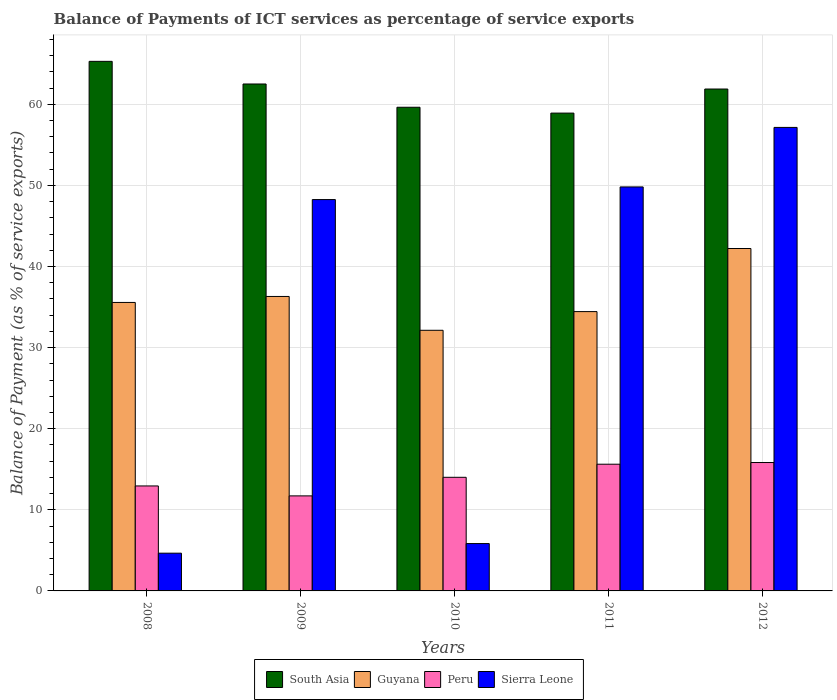How many groups of bars are there?
Make the answer very short. 5. Are the number of bars on each tick of the X-axis equal?
Your answer should be compact. Yes. How many bars are there on the 3rd tick from the right?
Keep it short and to the point. 4. What is the label of the 5th group of bars from the left?
Provide a short and direct response. 2012. In how many cases, is the number of bars for a given year not equal to the number of legend labels?
Give a very brief answer. 0. What is the balance of payments of ICT services in Peru in 2009?
Ensure brevity in your answer.  11.72. Across all years, what is the maximum balance of payments of ICT services in South Asia?
Keep it short and to the point. 65.3. Across all years, what is the minimum balance of payments of ICT services in Sierra Leone?
Offer a very short reply. 4.65. In which year was the balance of payments of ICT services in South Asia minimum?
Your answer should be compact. 2011. What is the total balance of payments of ICT services in South Asia in the graph?
Ensure brevity in your answer.  308.25. What is the difference between the balance of payments of ICT services in Peru in 2008 and that in 2011?
Provide a short and direct response. -2.68. What is the difference between the balance of payments of ICT services in Peru in 2011 and the balance of payments of ICT services in South Asia in 2012?
Provide a short and direct response. -46.26. What is the average balance of payments of ICT services in Sierra Leone per year?
Give a very brief answer. 33.14. In the year 2008, what is the difference between the balance of payments of ICT services in South Asia and balance of payments of ICT services in Sierra Leone?
Your answer should be very brief. 60.64. What is the ratio of the balance of payments of ICT services in South Asia in 2010 to that in 2012?
Keep it short and to the point. 0.96. What is the difference between the highest and the second highest balance of payments of ICT services in Peru?
Offer a very short reply. 0.21. What is the difference between the highest and the lowest balance of payments of ICT services in Guyana?
Provide a short and direct response. 10.08. In how many years, is the balance of payments of ICT services in Peru greater than the average balance of payments of ICT services in Peru taken over all years?
Provide a short and direct response. 2. Is it the case that in every year, the sum of the balance of payments of ICT services in Guyana and balance of payments of ICT services in South Asia is greater than the sum of balance of payments of ICT services in Sierra Leone and balance of payments of ICT services in Peru?
Make the answer very short. Yes. What does the 1st bar from the left in 2011 represents?
Keep it short and to the point. South Asia. What does the 4th bar from the right in 2011 represents?
Ensure brevity in your answer.  South Asia. What is the difference between two consecutive major ticks on the Y-axis?
Give a very brief answer. 10. Are the values on the major ticks of Y-axis written in scientific E-notation?
Offer a terse response. No. Does the graph contain any zero values?
Give a very brief answer. No. Where does the legend appear in the graph?
Your answer should be very brief. Bottom center. How many legend labels are there?
Ensure brevity in your answer.  4. How are the legend labels stacked?
Ensure brevity in your answer.  Horizontal. What is the title of the graph?
Your answer should be compact. Balance of Payments of ICT services as percentage of service exports. What is the label or title of the Y-axis?
Your response must be concise. Balance of Payment (as % of service exports). What is the Balance of Payment (as % of service exports) of South Asia in 2008?
Your answer should be compact. 65.3. What is the Balance of Payment (as % of service exports) of Guyana in 2008?
Your answer should be compact. 35.57. What is the Balance of Payment (as % of service exports) in Peru in 2008?
Keep it short and to the point. 12.94. What is the Balance of Payment (as % of service exports) of Sierra Leone in 2008?
Your response must be concise. 4.65. What is the Balance of Payment (as % of service exports) of South Asia in 2009?
Your answer should be very brief. 62.51. What is the Balance of Payment (as % of service exports) in Guyana in 2009?
Provide a succinct answer. 36.31. What is the Balance of Payment (as % of service exports) in Peru in 2009?
Your answer should be compact. 11.72. What is the Balance of Payment (as % of service exports) of Sierra Leone in 2009?
Offer a very short reply. 48.26. What is the Balance of Payment (as % of service exports) in South Asia in 2010?
Keep it short and to the point. 59.64. What is the Balance of Payment (as % of service exports) in Guyana in 2010?
Offer a terse response. 32.14. What is the Balance of Payment (as % of service exports) of Peru in 2010?
Your answer should be very brief. 14.01. What is the Balance of Payment (as % of service exports) in Sierra Leone in 2010?
Offer a terse response. 5.84. What is the Balance of Payment (as % of service exports) of South Asia in 2011?
Give a very brief answer. 58.92. What is the Balance of Payment (as % of service exports) in Guyana in 2011?
Make the answer very short. 34.44. What is the Balance of Payment (as % of service exports) in Peru in 2011?
Give a very brief answer. 15.62. What is the Balance of Payment (as % of service exports) in Sierra Leone in 2011?
Ensure brevity in your answer.  49.81. What is the Balance of Payment (as % of service exports) of South Asia in 2012?
Ensure brevity in your answer.  61.89. What is the Balance of Payment (as % of service exports) in Guyana in 2012?
Ensure brevity in your answer.  42.22. What is the Balance of Payment (as % of service exports) of Peru in 2012?
Your response must be concise. 15.83. What is the Balance of Payment (as % of service exports) of Sierra Leone in 2012?
Ensure brevity in your answer.  57.15. Across all years, what is the maximum Balance of Payment (as % of service exports) of South Asia?
Keep it short and to the point. 65.3. Across all years, what is the maximum Balance of Payment (as % of service exports) in Guyana?
Offer a terse response. 42.22. Across all years, what is the maximum Balance of Payment (as % of service exports) of Peru?
Provide a succinct answer. 15.83. Across all years, what is the maximum Balance of Payment (as % of service exports) in Sierra Leone?
Offer a terse response. 57.15. Across all years, what is the minimum Balance of Payment (as % of service exports) in South Asia?
Your answer should be very brief. 58.92. Across all years, what is the minimum Balance of Payment (as % of service exports) in Guyana?
Keep it short and to the point. 32.14. Across all years, what is the minimum Balance of Payment (as % of service exports) of Peru?
Give a very brief answer. 11.72. Across all years, what is the minimum Balance of Payment (as % of service exports) of Sierra Leone?
Offer a terse response. 4.65. What is the total Balance of Payment (as % of service exports) of South Asia in the graph?
Provide a short and direct response. 308.25. What is the total Balance of Payment (as % of service exports) in Guyana in the graph?
Give a very brief answer. 180.68. What is the total Balance of Payment (as % of service exports) in Peru in the graph?
Your answer should be very brief. 70.13. What is the total Balance of Payment (as % of service exports) of Sierra Leone in the graph?
Your response must be concise. 165.72. What is the difference between the Balance of Payment (as % of service exports) of South Asia in 2008 and that in 2009?
Your answer should be very brief. 2.79. What is the difference between the Balance of Payment (as % of service exports) in Guyana in 2008 and that in 2009?
Offer a very short reply. -0.74. What is the difference between the Balance of Payment (as % of service exports) of Peru in 2008 and that in 2009?
Keep it short and to the point. 1.22. What is the difference between the Balance of Payment (as % of service exports) in Sierra Leone in 2008 and that in 2009?
Keep it short and to the point. -43.6. What is the difference between the Balance of Payment (as % of service exports) of South Asia in 2008 and that in 2010?
Keep it short and to the point. 5.66. What is the difference between the Balance of Payment (as % of service exports) of Guyana in 2008 and that in 2010?
Give a very brief answer. 3.43. What is the difference between the Balance of Payment (as % of service exports) in Peru in 2008 and that in 2010?
Give a very brief answer. -1.07. What is the difference between the Balance of Payment (as % of service exports) in Sierra Leone in 2008 and that in 2010?
Provide a short and direct response. -1.18. What is the difference between the Balance of Payment (as % of service exports) in South Asia in 2008 and that in 2011?
Make the answer very short. 6.38. What is the difference between the Balance of Payment (as % of service exports) in Guyana in 2008 and that in 2011?
Offer a terse response. 1.13. What is the difference between the Balance of Payment (as % of service exports) of Peru in 2008 and that in 2011?
Your answer should be compact. -2.68. What is the difference between the Balance of Payment (as % of service exports) of Sierra Leone in 2008 and that in 2011?
Your answer should be very brief. -45.16. What is the difference between the Balance of Payment (as % of service exports) in South Asia in 2008 and that in 2012?
Provide a succinct answer. 3.41. What is the difference between the Balance of Payment (as % of service exports) in Guyana in 2008 and that in 2012?
Provide a short and direct response. -6.65. What is the difference between the Balance of Payment (as % of service exports) of Peru in 2008 and that in 2012?
Offer a terse response. -2.89. What is the difference between the Balance of Payment (as % of service exports) of Sierra Leone in 2008 and that in 2012?
Your answer should be very brief. -52.5. What is the difference between the Balance of Payment (as % of service exports) in South Asia in 2009 and that in 2010?
Make the answer very short. 2.87. What is the difference between the Balance of Payment (as % of service exports) in Guyana in 2009 and that in 2010?
Provide a short and direct response. 4.17. What is the difference between the Balance of Payment (as % of service exports) in Peru in 2009 and that in 2010?
Your response must be concise. -2.29. What is the difference between the Balance of Payment (as % of service exports) in Sierra Leone in 2009 and that in 2010?
Make the answer very short. 42.42. What is the difference between the Balance of Payment (as % of service exports) of South Asia in 2009 and that in 2011?
Offer a very short reply. 3.59. What is the difference between the Balance of Payment (as % of service exports) of Guyana in 2009 and that in 2011?
Keep it short and to the point. 1.87. What is the difference between the Balance of Payment (as % of service exports) of Peru in 2009 and that in 2011?
Offer a very short reply. -3.9. What is the difference between the Balance of Payment (as % of service exports) of Sierra Leone in 2009 and that in 2011?
Your answer should be very brief. -1.56. What is the difference between the Balance of Payment (as % of service exports) in South Asia in 2009 and that in 2012?
Offer a very short reply. 0.62. What is the difference between the Balance of Payment (as % of service exports) in Guyana in 2009 and that in 2012?
Your response must be concise. -5.91. What is the difference between the Balance of Payment (as % of service exports) in Peru in 2009 and that in 2012?
Offer a terse response. -4.11. What is the difference between the Balance of Payment (as % of service exports) of Sierra Leone in 2009 and that in 2012?
Make the answer very short. -8.9. What is the difference between the Balance of Payment (as % of service exports) in South Asia in 2010 and that in 2011?
Your response must be concise. 0.72. What is the difference between the Balance of Payment (as % of service exports) in Guyana in 2010 and that in 2011?
Keep it short and to the point. -2.3. What is the difference between the Balance of Payment (as % of service exports) of Peru in 2010 and that in 2011?
Give a very brief answer. -1.61. What is the difference between the Balance of Payment (as % of service exports) of Sierra Leone in 2010 and that in 2011?
Ensure brevity in your answer.  -43.98. What is the difference between the Balance of Payment (as % of service exports) of South Asia in 2010 and that in 2012?
Offer a very short reply. -2.25. What is the difference between the Balance of Payment (as % of service exports) in Guyana in 2010 and that in 2012?
Make the answer very short. -10.08. What is the difference between the Balance of Payment (as % of service exports) of Peru in 2010 and that in 2012?
Offer a terse response. -1.82. What is the difference between the Balance of Payment (as % of service exports) of Sierra Leone in 2010 and that in 2012?
Offer a terse response. -51.31. What is the difference between the Balance of Payment (as % of service exports) in South Asia in 2011 and that in 2012?
Make the answer very short. -2.97. What is the difference between the Balance of Payment (as % of service exports) in Guyana in 2011 and that in 2012?
Give a very brief answer. -7.78. What is the difference between the Balance of Payment (as % of service exports) of Peru in 2011 and that in 2012?
Offer a terse response. -0.21. What is the difference between the Balance of Payment (as % of service exports) in Sierra Leone in 2011 and that in 2012?
Offer a terse response. -7.34. What is the difference between the Balance of Payment (as % of service exports) of South Asia in 2008 and the Balance of Payment (as % of service exports) of Guyana in 2009?
Your answer should be very brief. 28.99. What is the difference between the Balance of Payment (as % of service exports) in South Asia in 2008 and the Balance of Payment (as % of service exports) in Peru in 2009?
Provide a short and direct response. 53.58. What is the difference between the Balance of Payment (as % of service exports) of South Asia in 2008 and the Balance of Payment (as % of service exports) of Sierra Leone in 2009?
Provide a succinct answer. 17.04. What is the difference between the Balance of Payment (as % of service exports) of Guyana in 2008 and the Balance of Payment (as % of service exports) of Peru in 2009?
Make the answer very short. 23.85. What is the difference between the Balance of Payment (as % of service exports) of Guyana in 2008 and the Balance of Payment (as % of service exports) of Sierra Leone in 2009?
Your answer should be compact. -12.69. What is the difference between the Balance of Payment (as % of service exports) in Peru in 2008 and the Balance of Payment (as % of service exports) in Sierra Leone in 2009?
Your answer should be compact. -35.31. What is the difference between the Balance of Payment (as % of service exports) in South Asia in 2008 and the Balance of Payment (as % of service exports) in Guyana in 2010?
Keep it short and to the point. 33.16. What is the difference between the Balance of Payment (as % of service exports) of South Asia in 2008 and the Balance of Payment (as % of service exports) of Peru in 2010?
Give a very brief answer. 51.29. What is the difference between the Balance of Payment (as % of service exports) of South Asia in 2008 and the Balance of Payment (as % of service exports) of Sierra Leone in 2010?
Offer a very short reply. 59.46. What is the difference between the Balance of Payment (as % of service exports) in Guyana in 2008 and the Balance of Payment (as % of service exports) in Peru in 2010?
Give a very brief answer. 21.56. What is the difference between the Balance of Payment (as % of service exports) of Guyana in 2008 and the Balance of Payment (as % of service exports) of Sierra Leone in 2010?
Make the answer very short. 29.73. What is the difference between the Balance of Payment (as % of service exports) in Peru in 2008 and the Balance of Payment (as % of service exports) in Sierra Leone in 2010?
Keep it short and to the point. 7.11. What is the difference between the Balance of Payment (as % of service exports) of South Asia in 2008 and the Balance of Payment (as % of service exports) of Guyana in 2011?
Make the answer very short. 30.86. What is the difference between the Balance of Payment (as % of service exports) of South Asia in 2008 and the Balance of Payment (as % of service exports) of Peru in 2011?
Offer a very short reply. 49.68. What is the difference between the Balance of Payment (as % of service exports) in South Asia in 2008 and the Balance of Payment (as % of service exports) in Sierra Leone in 2011?
Your answer should be compact. 15.48. What is the difference between the Balance of Payment (as % of service exports) of Guyana in 2008 and the Balance of Payment (as % of service exports) of Peru in 2011?
Your answer should be very brief. 19.95. What is the difference between the Balance of Payment (as % of service exports) of Guyana in 2008 and the Balance of Payment (as % of service exports) of Sierra Leone in 2011?
Provide a short and direct response. -14.24. What is the difference between the Balance of Payment (as % of service exports) in Peru in 2008 and the Balance of Payment (as % of service exports) in Sierra Leone in 2011?
Offer a terse response. -36.87. What is the difference between the Balance of Payment (as % of service exports) of South Asia in 2008 and the Balance of Payment (as % of service exports) of Guyana in 2012?
Offer a terse response. 23.08. What is the difference between the Balance of Payment (as % of service exports) of South Asia in 2008 and the Balance of Payment (as % of service exports) of Peru in 2012?
Keep it short and to the point. 49.47. What is the difference between the Balance of Payment (as % of service exports) in South Asia in 2008 and the Balance of Payment (as % of service exports) in Sierra Leone in 2012?
Your answer should be compact. 8.15. What is the difference between the Balance of Payment (as % of service exports) of Guyana in 2008 and the Balance of Payment (as % of service exports) of Peru in 2012?
Provide a succinct answer. 19.74. What is the difference between the Balance of Payment (as % of service exports) in Guyana in 2008 and the Balance of Payment (as % of service exports) in Sierra Leone in 2012?
Offer a terse response. -21.58. What is the difference between the Balance of Payment (as % of service exports) in Peru in 2008 and the Balance of Payment (as % of service exports) in Sierra Leone in 2012?
Your answer should be very brief. -44.21. What is the difference between the Balance of Payment (as % of service exports) in South Asia in 2009 and the Balance of Payment (as % of service exports) in Guyana in 2010?
Give a very brief answer. 30.37. What is the difference between the Balance of Payment (as % of service exports) in South Asia in 2009 and the Balance of Payment (as % of service exports) in Peru in 2010?
Your answer should be very brief. 48.5. What is the difference between the Balance of Payment (as % of service exports) of South Asia in 2009 and the Balance of Payment (as % of service exports) of Sierra Leone in 2010?
Provide a short and direct response. 56.67. What is the difference between the Balance of Payment (as % of service exports) of Guyana in 2009 and the Balance of Payment (as % of service exports) of Peru in 2010?
Ensure brevity in your answer.  22.3. What is the difference between the Balance of Payment (as % of service exports) of Guyana in 2009 and the Balance of Payment (as % of service exports) of Sierra Leone in 2010?
Offer a terse response. 30.47. What is the difference between the Balance of Payment (as % of service exports) of Peru in 2009 and the Balance of Payment (as % of service exports) of Sierra Leone in 2010?
Provide a succinct answer. 5.88. What is the difference between the Balance of Payment (as % of service exports) of South Asia in 2009 and the Balance of Payment (as % of service exports) of Guyana in 2011?
Make the answer very short. 28.07. What is the difference between the Balance of Payment (as % of service exports) in South Asia in 2009 and the Balance of Payment (as % of service exports) in Peru in 2011?
Your response must be concise. 46.88. What is the difference between the Balance of Payment (as % of service exports) in South Asia in 2009 and the Balance of Payment (as % of service exports) in Sierra Leone in 2011?
Keep it short and to the point. 12.69. What is the difference between the Balance of Payment (as % of service exports) in Guyana in 2009 and the Balance of Payment (as % of service exports) in Peru in 2011?
Give a very brief answer. 20.69. What is the difference between the Balance of Payment (as % of service exports) of Guyana in 2009 and the Balance of Payment (as % of service exports) of Sierra Leone in 2011?
Your answer should be compact. -13.5. What is the difference between the Balance of Payment (as % of service exports) of Peru in 2009 and the Balance of Payment (as % of service exports) of Sierra Leone in 2011?
Your answer should be very brief. -38.09. What is the difference between the Balance of Payment (as % of service exports) in South Asia in 2009 and the Balance of Payment (as % of service exports) in Guyana in 2012?
Your response must be concise. 20.29. What is the difference between the Balance of Payment (as % of service exports) in South Asia in 2009 and the Balance of Payment (as % of service exports) in Peru in 2012?
Your response must be concise. 46.68. What is the difference between the Balance of Payment (as % of service exports) in South Asia in 2009 and the Balance of Payment (as % of service exports) in Sierra Leone in 2012?
Make the answer very short. 5.35. What is the difference between the Balance of Payment (as % of service exports) in Guyana in 2009 and the Balance of Payment (as % of service exports) in Peru in 2012?
Provide a short and direct response. 20.48. What is the difference between the Balance of Payment (as % of service exports) in Guyana in 2009 and the Balance of Payment (as % of service exports) in Sierra Leone in 2012?
Offer a very short reply. -20.84. What is the difference between the Balance of Payment (as % of service exports) in Peru in 2009 and the Balance of Payment (as % of service exports) in Sierra Leone in 2012?
Offer a terse response. -45.43. What is the difference between the Balance of Payment (as % of service exports) in South Asia in 2010 and the Balance of Payment (as % of service exports) in Guyana in 2011?
Your answer should be very brief. 25.2. What is the difference between the Balance of Payment (as % of service exports) of South Asia in 2010 and the Balance of Payment (as % of service exports) of Peru in 2011?
Your response must be concise. 44.02. What is the difference between the Balance of Payment (as % of service exports) of South Asia in 2010 and the Balance of Payment (as % of service exports) of Sierra Leone in 2011?
Offer a terse response. 9.82. What is the difference between the Balance of Payment (as % of service exports) of Guyana in 2010 and the Balance of Payment (as % of service exports) of Peru in 2011?
Your answer should be compact. 16.51. What is the difference between the Balance of Payment (as % of service exports) in Guyana in 2010 and the Balance of Payment (as % of service exports) in Sierra Leone in 2011?
Your response must be concise. -17.68. What is the difference between the Balance of Payment (as % of service exports) in Peru in 2010 and the Balance of Payment (as % of service exports) in Sierra Leone in 2011?
Make the answer very short. -35.8. What is the difference between the Balance of Payment (as % of service exports) in South Asia in 2010 and the Balance of Payment (as % of service exports) in Guyana in 2012?
Offer a terse response. 17.42. What is the difference between the Balance of Payment (as % of service exports) of South Asia in 2010 and the Balance of Payment (as % of service exports) of Peru in 2012?
Offer a very short reply. 43.81. What is the difference between the Balance of Payment (as % of service exports) in South Asia in 2010 and the Balance of Payment (as % of service exports) in Sierra Leone in 2012?
Your response must be concise. 2.49. What is the difference between the Balance of Payment (as % of service exports) of Guyana in 2010 and the Balance of Payment (as % of service exports) of Peru in 2012?
Keep it short and to the point. 16.3. What is the difference between the Balance of Payment (as % of service exports) of Guyana in 2010 and the Balance of Payment (as % of service exports) of Sierra Leone in 2012?
Offer a terse response. -25.02. What is the difference between the Balance of Payment (as % of service exports) of Peru in 2010 and the Balance of Payment (as % of service exports) of Sierra Leone in 2012?
Keep it short and to the point. -43.14. What is the difference between the Balance of Payment (as % of service exports) of South Asia in 2011 and the Balance of Payment (as % of service exports) of Guyana in 2012?
Your response must be concise. 16.7. What is the difference between the Balance of Payment (as % of service exports) in South Asia in 2011 and the Balance of Payment (as % of service exports) in Peru in 2012?
Your answer should be compact. 43.08. What is the difference between the Balance of Payment (as % of service exports) of South Asia in 2011 and the Balance of Payment (as % of service exports) of Sierra Leone in 2012?
Your answer should be compact. 1.76. What is the difference between the Balance of Payment (as % of service exports) in Guyana in 2011 and the Balance of Payment (as % of service exports) in Peru in 2012?
Provide a succinct answer. 18.61. What is the difference between the Balance of Payment (as % of service exports) of Guyana in 2011 and the Balance of Payment (as % of service exports) of Sierra Leone in 2012?
Offer a terse response. -22.71. What is the difference between the Balance of Payment (as % of service exports) in Peru in 2011 and the Balance of Payment (as % of service exports) in Sierra Leone in 2012?
Your answer should be compact. -41.53. What is the average Balance of Payment (as % of service exports) in South Asia per year?
Offer a very short reply. 61.65. What is the average Balance of Payment (as % of service exports) in Guyana per year?
Offer a very short reply. 36.14. What is the average Balance of Payment (as % of service exports) of Peru per year?
Ensure brevity in your answer.  14.03. What is the average Balance of Payment (as % of service exports) of Sierra Leone per year?
Give a very brief answer. 33.14. In the year 2008, what is the difference between the Balance of Payment (as % of service exports) of South Asia and Balance of Payment (as % of service exports) of Guyana?
Provide a short and direct response. 29.73. In the year 2008, what is the difference between the Balance of Payment (as % of service exports) of South Asia and Balance of Payment (as % of service exports) of Peru?
Ensure brevity in your answer.  52.35. In the year 2008, what is the difference between the Balance of Payment (as % of service exports) in South Asia and Balance of Payment (as % of service exports) in Sierra Leone?
Your answer should be compact. 60.64. In the year 2008, what is the difference between the Balance of Payment (as % of service exports) of Guyana and Balance of Payment (as % of service exports) of Peru?
Your response must be concise. 22.63. In the year 2008, what is the difference between the Balance of Payment (as % of service exports) of Guyana and Balance of Payment (as % of service exports) of Sierra Leone?
Provide a succinct answer. 30.92. In the year 2008, what is the difference between the Balance of Payment (as % of service exports) in Peru and Balance of Payment (as % of service exports) in Sierra Leone?
Your answer should be compact. 8.29. In the year 2009, what is the difference between the Balance of Payment (as % of service exports) of South Asia and Balance of Payment (as % of service exports) of Guyana?
Offer a very short reply. 26.2. In the year 2009, what is the difference between the Balance of Payment (as % of service exports) of South Asia and Balance of Payment (as % of service exports) of Peru?
Provide a short and direct response. 50.79. In the year 2009, what is the difference between the Balance of Payment (as % of service exports) of South Asia and Balance of Payment (as % of service exports) of Sierra Leone?
Offer a very short reply. 14.25. In the year 2009, what is the difference between the Balance of Payment (as % of service exports) in Guyana and Balance of Payment (as % of service exports) in Peru?
Ensure brevity in your answer.  24.59. In the year 2009, what is the difference between the Balance of Payment (as % of service exports) of Guyana and Balance of Payment (as % of service exports) of Sierra Leone?
Offer a very short reply. -11.95. In the year 2009, what is the difference between the Balance of Payment (as % of service exports) of Peru and Balance of Payment (as % of service exports) of Sierra Leone?
Keep it short and to the point. -36.54. In the year 2010, what is the difference between the Balance of Payment (as % of service exports) in South Asia and Balance of Payment (as % of service exports) in Guyana?
Make the answer very short. 27.5. In the year 2010, what is the difference between the Balance of Payment (as % of service exports) in South Asia and Balance of Payment (as % of service exports) in Peru?
Your answer should be very brief. 45.63. In the year 2010, what is the difference between the Balance of Payment (as % of service exports) of South Asia and Balance of Payment (as % of service exports) of Sierra Leone?
Provide a short and direct response. 53.8. In the year 2010, what is the difference between the Balance of Payment (as % of service exports) of Guyana and Balance of Payment (as % of service exports) of Peru?
Make the answer very short. 18.13. In the year 2010, what is the difference between the Balance of Payment (as % of service exports) of Guyana and Balance of Payment (as % of service exports) of Sierra Leone?
Provide a succinct answer. 26.3. In the year 2010, what is the difference between the Balance of Payment (as % of service exports) of Peru and Balance of Payment (as % of service exports) of Sierra Leone?
Keep it short and to the point. 8.17. In the year 2011, what is the difference between the Balance of Payment (as % of service exports) of South Asia and Balance of Payment (as % of service exports) of Guyana?
Your answer should be very brief. 24.48. In the year 2011, what is the difference between the Balance of Payment (as % of service exports) of South Asia and Balance of Payment (as % of service exports) of Peru?
Keep it short and to the point. 43.29. In the year 2011, what is the difference between the Balance of Payment (as % of service exports) in South Asia and Balance of Payment (as % of service exports) in Sierra Leone?
Make the answer very short. 9.1. In the year 2011, what is the difference between the Balance of Payment (as % of service exports) of Guyana and Balance of Payment (as % of service exports) of Peru?
Provide a short and direct response. 18.82. In the year 2011, what is the difference between the Balance of Payment (as % of service exports) of Guyana and Balance of Payment (as % of service exports) of Sierra Leone?
Make the answer very short. -15.37. In the year 2011, what is the difference between the Balance of Payment (as % of service exports) in Peru and Balance of Payment (as % of service exports) in Sierra Leone?
Ensure brevity in your answer.  -34.19. In the year 2012, what is the difference between the Balance of Payment (as % of service exports) in South Asia and Balance of Payment (as % of service exports) in Guyana?
Keep it short and to the point. 19.67. In the year 2012, what is the difference between the Balance of Payment (as % of service exports) of South Asia and Balance of Payment (as % of service exports) of Peru?
Give a very brief answer. 46.06. In the year 2012, what is the difference between the Balance of Payment (as % of service exports) in South Asia and Balance of Payment (as % of service exports) in Sierra Leone?
Keep it short and to the point. 4.73. In the year 2012, what is the difference between the Balance of Payment (as % of service exports) of Guyana and Balance of Payment (as % of service exports) of Peru?
Give a very brief answer. 26.39. In the year 2012, what is the difference between the Balance of Payment (as % of service exports) of Guyana and Balance of Payment (as % of service exports) of Sierra Leone?
Make the answer very short. -14.93. In the year 2012, what is the difference between the Balance of Payment (as % of service exports) in Peru and Balance of Payment (as % of service exports) in Sierra Leone?
Provide a succinct answer. -41.32. What is the ratio of the Balance of Payment (as % of service exports) in South Asia in 2008 to that in 2009?
Ensure brevity in your answer.  1.04. What is the ratio of the Balance of Payment (as % of service exports) of Guyana in 2008 to that in 2009?
Offer a very short reply. 0.98. What is the ratio of the Balance of Payment (as % of service exports) in Peru in 2008 to that in 2009?
Offer a terse response. 1.1. What is the ratio of the Balance of Payment (as % of service exports) of Sierra Leone in 2008 to that in 2009?
Your response must be concise. 0.1. What is the ratio of the Balance of Payment (as % of service exports) in South Asia in 2008 to that in 2010?
Your answer should be very brief. 1.09. What is the ratio of the Balance of Payment (as % of service exports) in Guyana in 2008 to that in 2010?
Your response must be concise. 1.11. What is the ratio of the Balance of Payment (as % of service exports) of Peru in 2008 to that in 2010?
Keep it short and to the point. 0.92. What is the ratio of the Balance of Payment (as % of service exports) in Sierra Leone in 2008 to that in 2010?
Keep it short and to the point. 0.8. What is the ratio of the Balance of Payment (as % of service exports) in South Asia in 2008 to that in 2011?
Make the answer very short. 1.11. What is the ratio of the Balance of Payment (as % of service exports) in Guyana in 2008 to that in 2011?
Offer a very short reply. 1.03. What is the ratio of the Balance of Payment (as % of service exports) in Peru in 2008 to that in 2011?
Provide a succinct answer. 0.83. What is the ratio of the Balance of Payment (as % of service exports) in Sierra Leone in 2008 to that in 2011?
Offer a very short reply. 0.09. What is the ratio of the Balance of Payment (as % of service exports) of South Asia in 2008 to that in 2012?
Your answer should be compact. 1.06. What is the ratio of the Balance of Payment (as % of service exports) in Guyana in 2008 to that in 2012?
Give a very brief answer. 0.84. What is the ratio of the Balance of Payment (as % of service exports) of Peru in 2008 to that in 2012?
Ensure brevity in your answer.  0.82. What is the ratio of the Balance of Payment (as % of service exports) of Sierra Leone in 2008 to that in 2012?
Ensure brevity in your answer.  0.08. What is the ratio of the Balance of Payment (as % of service exports) in South Asia in 2009 to that in 2010?
Ensure brevity in your answer.  1.05. What is the ratio of the Balance of Payment (as % of service exports) of Guyana in 2009 to that in 2010?
Make the answer very short. 1.13. What is the ratio of the Balance of Payment (as % of service exports) of Peru in 2009 to that in 2010?
Provide a short and direct response. 0.84. What is the ratio of the Balance of Payment (as % of service exports) of Sierra Leone in 2009 to that in 2010?
Ensure brevity in your answer.  8.27. What is the ratio of the Balance of Payment (as % of service exports) in South Asia in 2009 to that in 2011?
Your answer should be very brief. 1.06. What is the ratio of the Balance of Payment (as % of service exports) in Guyana in 2009 to that in 2011?
Provide a succinct answer. 1.05. What is the ratio of the Balance of Payment (as % of service exports) in Peru in 2009 to that in 2011?
Provide a succinct answer. 0.75. What is the ratio of the Balance of Payment (as % of service exports) of Sierra Leone in 2009 to that in 2011?
Give a very brief answer. 0.97. What is the ratio of the Balance of Payment (as % of service exports) of Guyana in 2009 to that in 2012?
Provide a short and direct response. 0.86. What is the ratio of the Balance of Payment (as % of service exports) in Peru in 2009 to that in 2012?
Your answer should be very brief. 0.74. What is the ratio of the Balance of Payment (as % of service exports) of Sierra Leone in 2009 to that in 2012?
Ensure brevity in your answer.  0.84. What is the ratio of the Balance of Payment (as % of service exports) of South Asia in 2010 to that in 2011?
Offer a very short reply. 1.01. What is the ratio of the Balance of Payment (as % of service exports) of Guyana in 2010 to that in 2011?
Offer a terse response. 0.93. What is the ratio of the Balance of Payment (as % of service exports) of Peru in 2010 to that in 2011?
Offer a terse response. 0.9. What is the ratio of the Balance of Payment (as % of service exports) of Sierra Leone in 2010 to that in 2011?
Your response must be concise. 0.12. What is the ratio of the Balance of Payment (as % of service exports) of South Asia in 2010 to that in 2012?
Offer a terse response. 0.96. What is the ratio of the Balance of Payment (as % of service exports) of Guyana in 2010 to that in 2012?
Your answer should be very brief. 0.76. What is the ratio of the Balance of Payment (as % of service exports) of Peru in 2010 to that in 2012?
Your answer should be very brief. 0.88. What is the ratio of the Balance of Payment (as % of service exports) of Sierra Leone in 2010 to that in 2012?
Offer a very short reply. 0.1. What is the ratio of the Balance of Payment (as % of service exports) of South Asia in 2011 to that in 2012?
Your response must be concise. 0.95. What is the ratio of the Balance of Payment (as % of service exports) in Guyana in 2011 to that in 2012?
Ensure brevity in your answer.  0.82. What is the ratio of the Balance of Payment (as % of service exports) in Sierra Leone in 2011 to that in 2012?
Give a very brief answer. 0.87. What is the difference between the highest and the second highest Balance of Payment (as % of service exports) in South Asia?
Your answer should be compact. 2.79. What is the difference between the highest and the second highest Balance of Payment (as % of service exports) of Guyana?
Keep it short and to the point. 5.91. What is the difference between the highest and the second highest Balance of Payment (as % of service exports) in Peru?
Ensure brevity in your answer.  0.21. What is the difference between the highest and the second highest Balance of Payment (as % of service exports) in Sierra Leone?
Offer a terse response. 7.34. What is the difference between the highest and the lowest Balance of Payment (as % of service exports) of South Asia?
Make the answer very short. 6.38. What is the difference between the highest and the lowest Balance of Payment (as % of service exports) in Guyana?
Ensure brevity in your answer.  10.08. What is the difference between the highest and the lowest Balance of Payment (as % of service exports) of Peru?
Give a very brief answer. 4.11. What is the difference between the highest and the lowest Balance of Payment (as % of service exports) in Sierra Leone?
Keep it short and to the point. 52.5. 